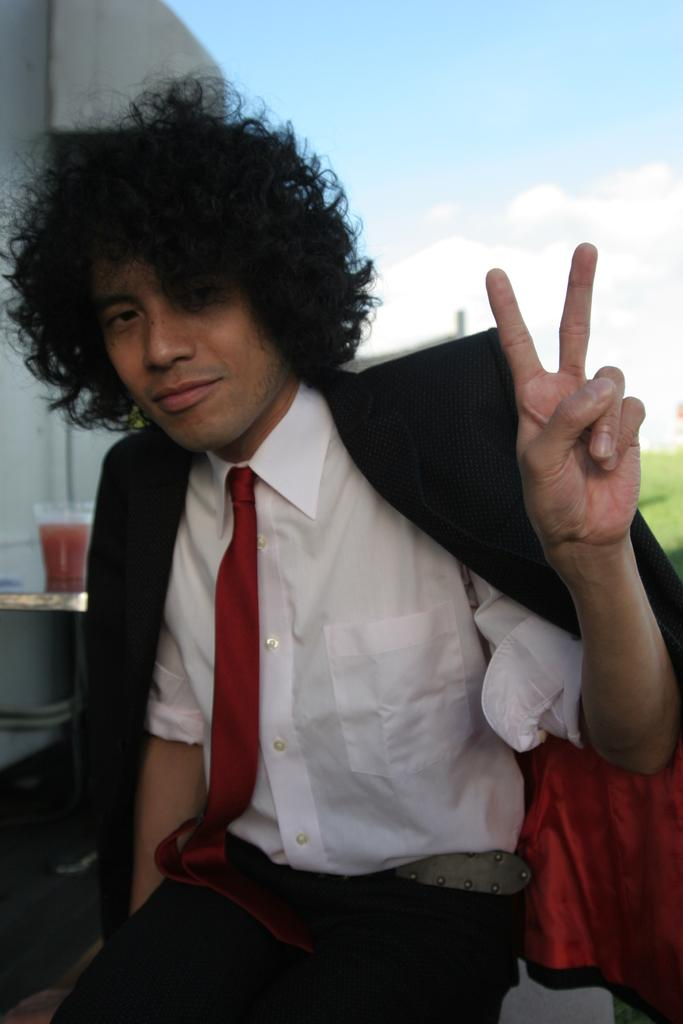What is the main subject of the image? There is a person in the image. What is the person wearing on their upper body? The person is wearing a white shirt and a black coat. What type of accessory is the person wearing around their neck? The person is wearing a red color tie. What can be seen in the background of the image? The sky is visible in the background of the image. What type of bread is the person eating in the image? There is no bread present in the image; the person is holding a glass with a drink. 